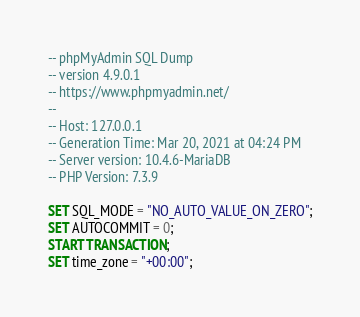Convert code to text. <code><loc_0><loc_0><loc_500><loc_500><_SQL_>-- phpMyAdmin SQL Dump
-- version 4.9.0.1
-- https://www.phpmyadmin.net/
--
-- Host: 127.0.0.1
-- Generation Time: Mar 20, 2021 at 04:24 PM
-- Server version: 10.4.6-MariaDB
-- PHP Version: 7.3.9

SET SQL_MODE = "NO_AUTO_VALUE_ON_ZERO";
SET AUTOCOMMIT = 0;
START TRANSACTION;
SET time_zone = "+00:00";

</code> 